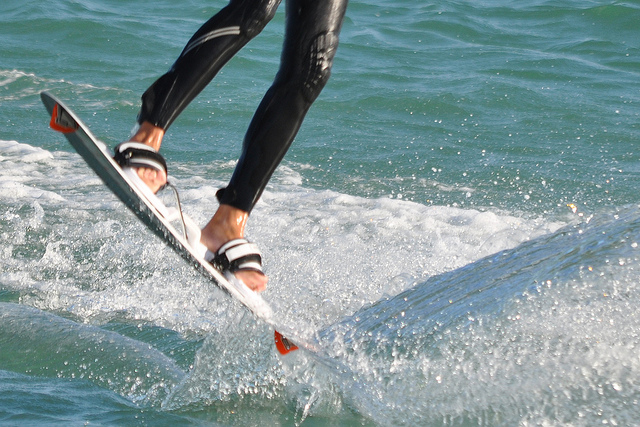Is the person in the photo wearing tennis shoes? The person is not wearing tennis shoes; instead, they're sporting a pair of black sandals with straps, suitable for water activities. 